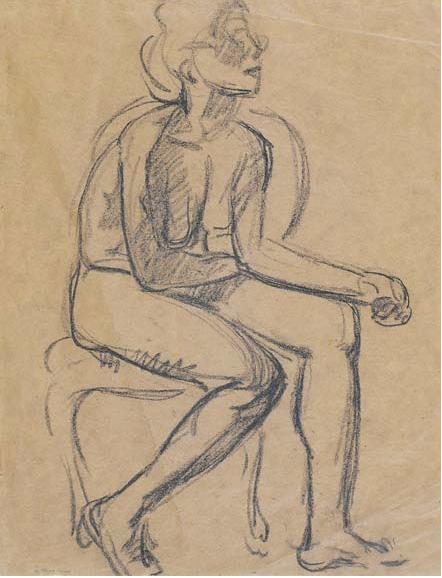What's happening in the scene? The image features a striking black-and-white sketch of a figure seated on what appears to be a stool or chair. The sketch highlights the contours and lines of the human form in a relaxed posture, with the figure's legs crossed and arms resting loosely on their knees. The head is turned to the side, evoking a contemplative or introspective mood. Drawn in a loose and expressive gestural style, the piece is reminiscent of early 20th-century portraiture. The use of a limited color palette keeps the focus on the figure itself, allowing for a deep appreciation of its anatomical precision and the flow of its lines. The light beige background provides a subtle contrast, further emphasizing the timeless and solitary nature of the scene. This sketch is likely a study in human anatomy and movement, capturing a moment of quiet reflection. 